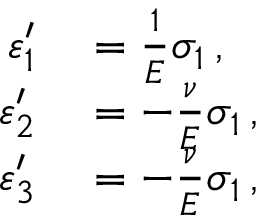Convert formula to latex. <formula><loc_0><loc_0><loc_500><loc_500>\begin{array} { r l } { \varepsilon _ { 1 } ^ { \prime } } & = { \frac { 1 } { E } } \sigma _ { 1 } \, , } \\ { \varepsilon _ { 2 } ^ { \prime } } & = - { \frac { \nu } { E } } \sigma _ { 1 } \, , } \\ { \varepsilon _ { 3 } ^ { \prime } } & = - { \frac { \nu } { E } } \sigma _ { 1 } \, , } \end{array}</formula> 